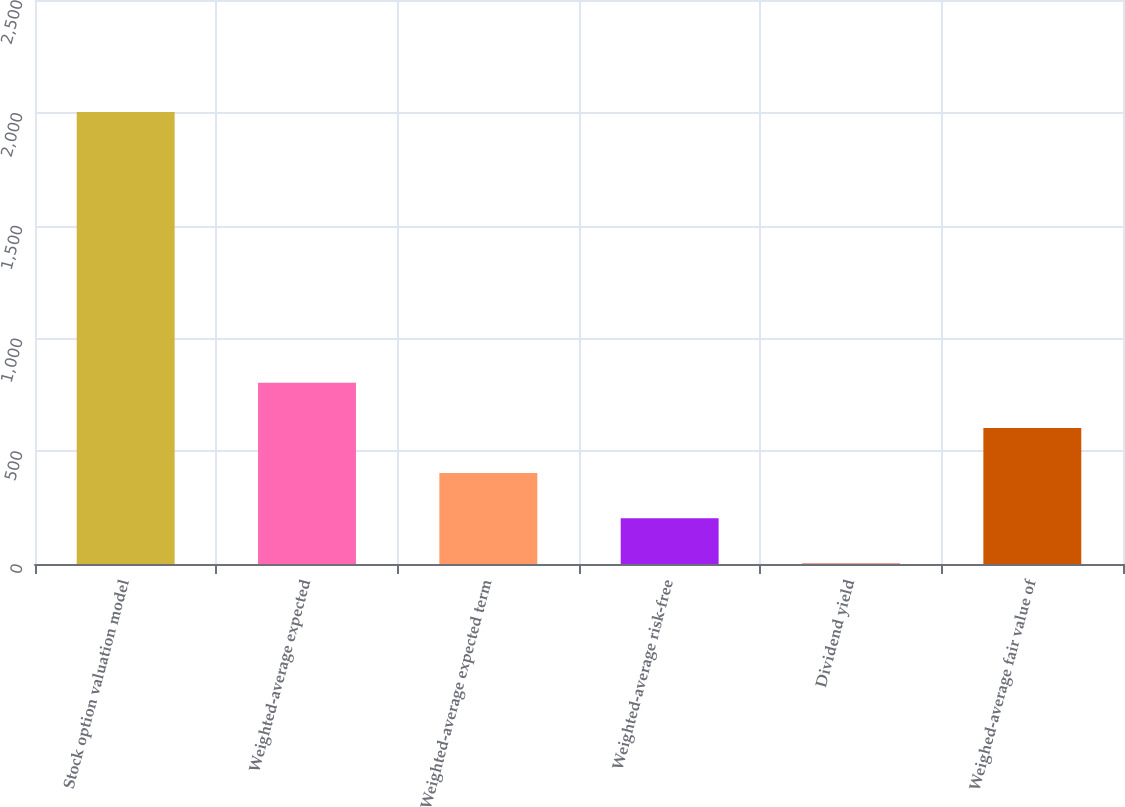Convert chart to OTSL. <chart><loc_0><loc_0><loc_500><loc_500><bar_chart><fcel>Stock option valuation model<fcel>Weighted-average expected<fcel>Weighted-average expected term<fcel>Weighted-average risk-free<fcel>Dividend yield<fcel>Weighed-average fair value of<nl><fcel>2004<fcel>803.16<fcel>402.88<fcel>202.74<fcel>2.6<fcel>603.02<nl></chart> 